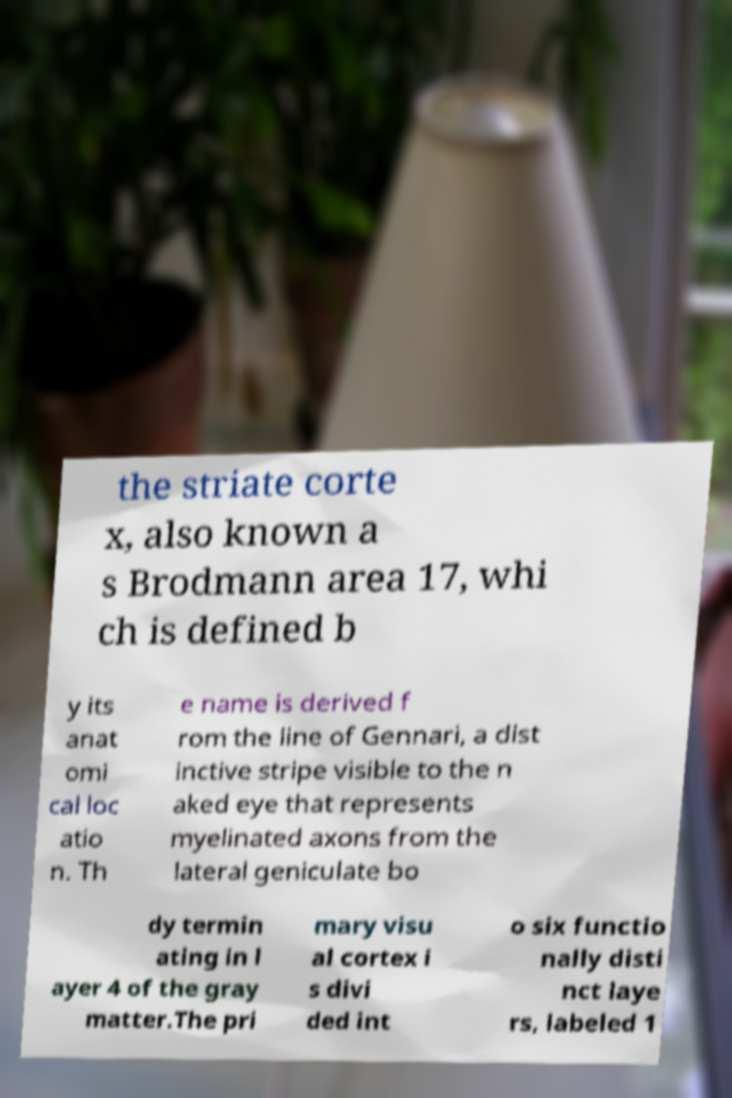Can you read and provide the text displayed in the image?This photo seems to have some interesting text. Can you extract and type it out for me? the striate corte x, also known a s Brodmann area 17, whi ch is defined b y its anat omi cal loc atio n. Th e name is derived f rom the line of Gennari, a dist inctive stripe visible to the n aked eye that represents myelinated axons from the lateral geniculate bo dy termin ating in l ayer 4 of the gray matter.The pri mary visu al cortex i s divi ded int o six functio nally disti nct laye rs, labeled 1 